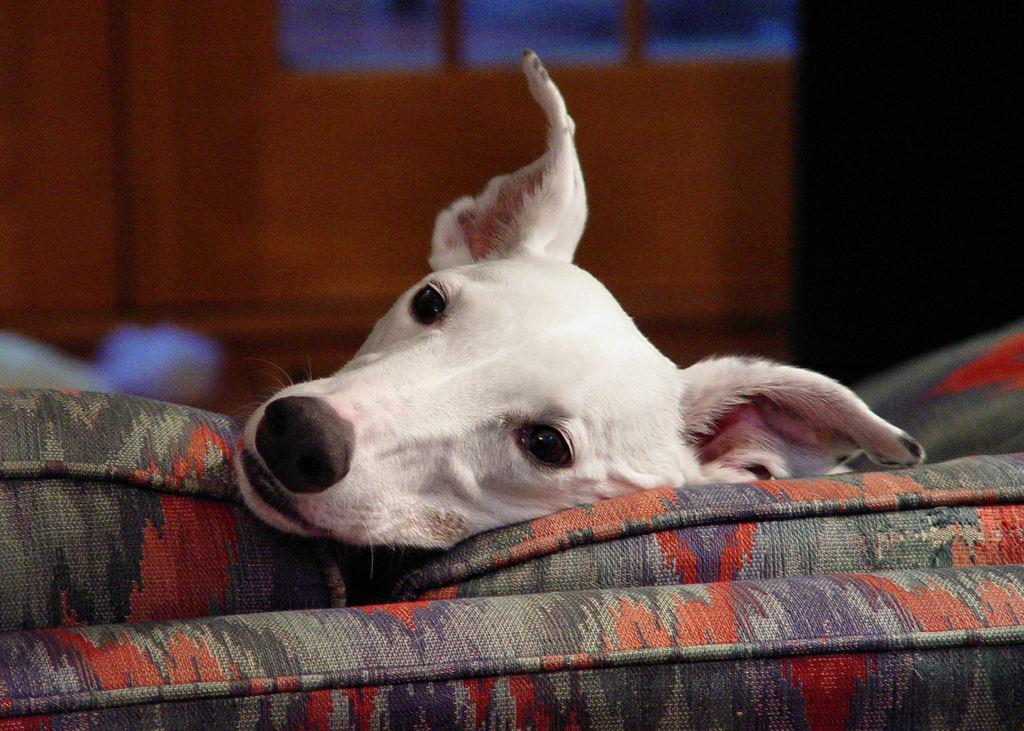Can you describe this image briefly? In this picture we can see the head of a dog on a colorful object. Background is blurry. 